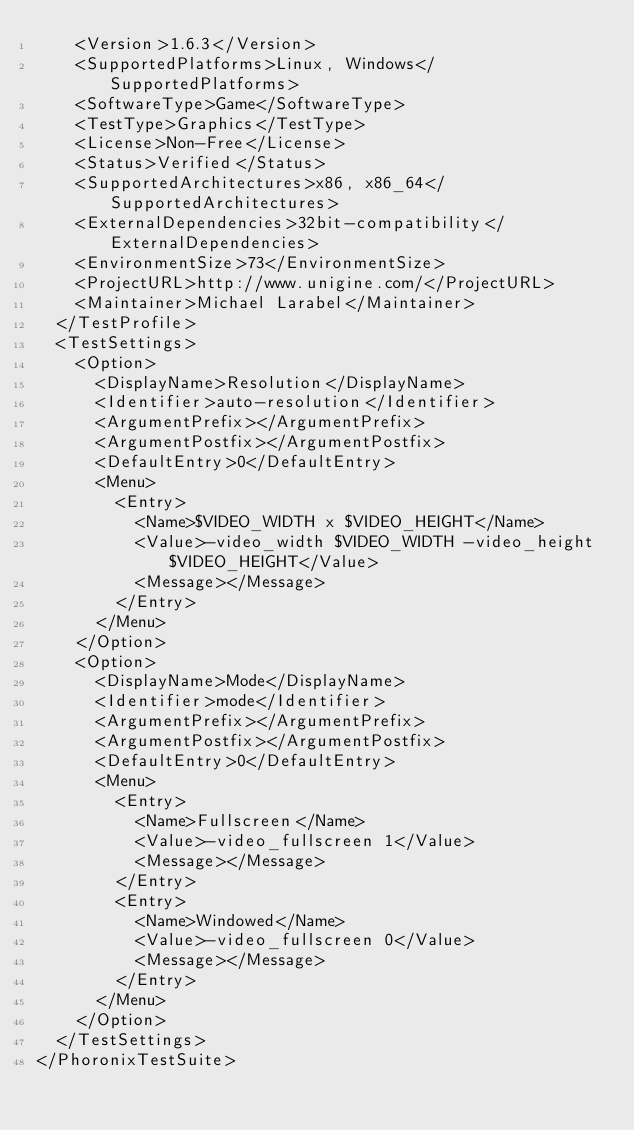Convert code to text. <code><loc_0><loc_0><loc_500><loc_500><_XML_>    <Version>1.6.3</Version>
    <SupportedPlatforms>Linux, Windows</SupportedPlatforms>
    <SoftwareType>Game</SoftwareType>
    <TestType>Graphics</TestType>
    <License>Non-Free</License>
    <Status>Verified</Status>
    <SupportedArchitectures>x86, x86_64</SupportedArchitectures>
    <ExternalDependencies>32bit-compatibility</ExternalDependencies>
    <EnvironmentSize>73</EnvironmentSize>
    <ProjectURL>http://www.unigine.com/</ProjectURL>
    <Maintainer>Michael Larabel</Maintainer>
  </TestProfile>
  <TestSettings>
    <Option>
      <DisplayName>Resolution</DisplayName>
      <Identifier>auto-resolution</Identifier>
      <ArgumentPrefix></ArgumentPrefix>
      <ArgumentPostfix></ArgumentPostfix>
      <DefaultEntry>0</DefaultEntry>
      <Menu>
        <Entry>
          <Name>$VIDEO_WIDTH x $VIDEO_HEIGHT</Name>
          <Value>-video_width $VIDEO_WIDTH -video_height $VIDEO_HEIGHT</Value>
          <Message></Message>
        </Entry>
      </Menu>
    </Option>
    <Option>
      <DisplayName>Mode</DisplayName>
      <Identifier>mode</Identifier>
      <ArgumentPrefix></ArgumentPrefix>
      <ArgumentPostfix></ArgumentPostfix>
      <DefaultEntry>0</DefaultEntry>
      <Menu>
        <Entry>
          <Name>Fullscreen</Name>
          <Value>-video_fullscreen 1</Value>
          <Message></Message>
        </Entry>
        <Entry>
          <Name>Windowed</Name>
          <Value>-video_fullscreen 0</Value>
          <Message></Message>
        </Entry>
      </Menu>
    </Option>
  </TestSettings>
</PhoronixTestSuite>
</code> 